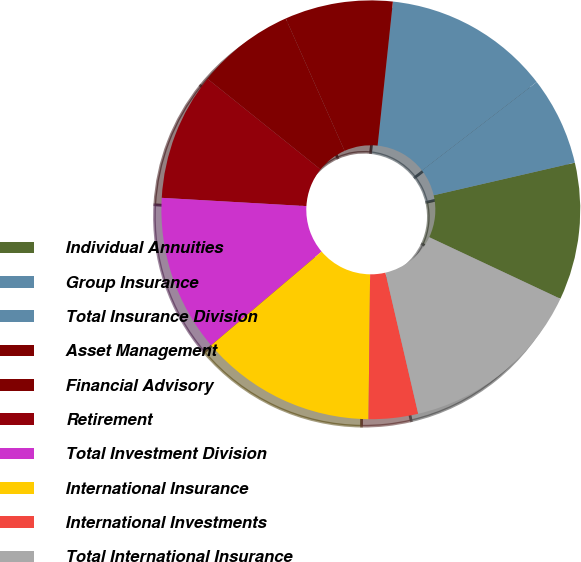<chart> <loc_0><loc_0><loc_500><loc_500><pie_chart><fcel>Individual Annuities<fcel>Group Insurance<fcel>Total Insurance Division<fcel>Asset Management<fcel>Financial Advisory<fcel>Retirement<fcel>Total Investment Division<fcel>International Insurance<fcel>International Investments<fcel>Total International Insurance<nl><fcel>10.6%<fcel>6.83%<fcel>12.87%<fcel>8.34%<fcel>7.58%<fcel>9.85%<fcel>12.11%<fcel>13.62%<fcel>3.81%<fcel>14.38%<nl></chart> 